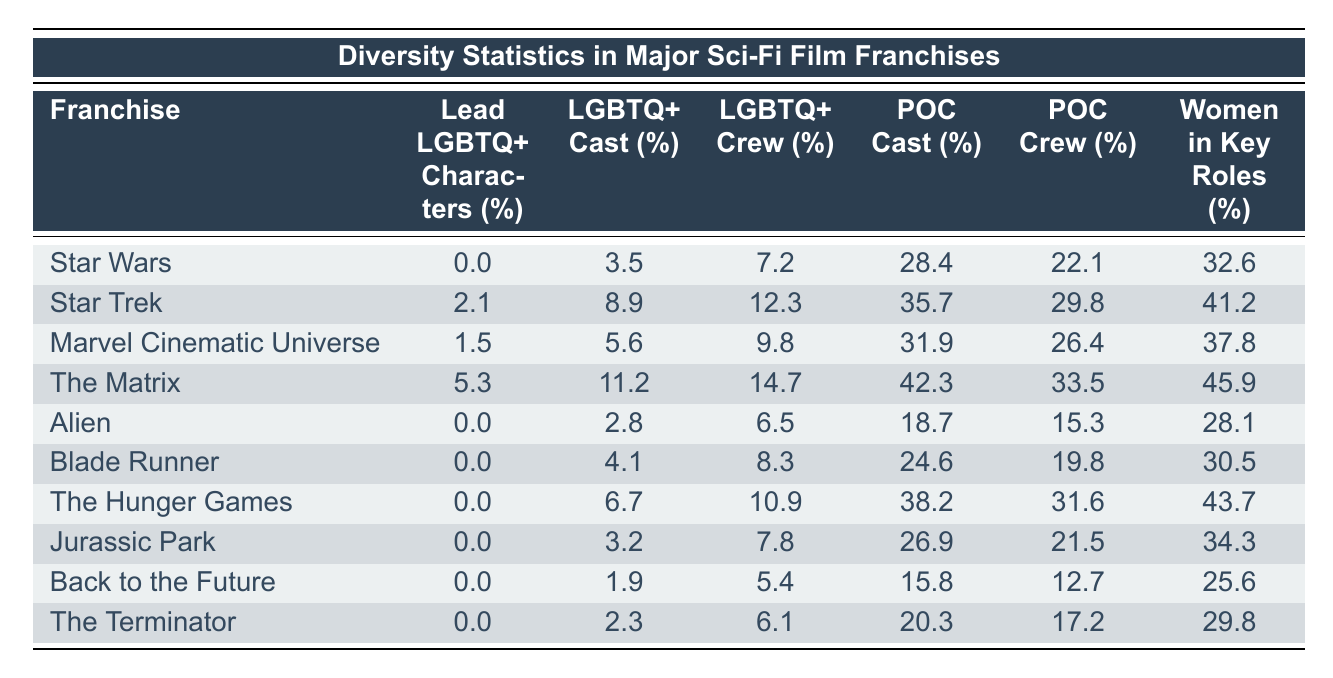What is the percentage of lead LGBTQ+ characters in the "Star Wars" franchise? In the table, under the column "Lead LGBTQ+ Characters (%)" for "Star Wars," the value is 0.0%.
Answer: 0.0% Which franchise has the highest percentage of LGBTQ+ cast? The table shows that "The Matrix" has the highest percentage of LGBTQ+ cast at 11.2%.
Answer: The Matrix What percentage of crew members in the "Star Trek" franchise identify as LGBTQ+? Referring to the "Star Trek" row in the "LGBTQ+ Crew (%)" column, the value is 12.3%.
Answer: 12.3% Which franchise has the lowest percentage of POC cast members? Looking at the "POC Cast (%)" column, "Alien" has the lowest percentage at 18.7%.
Answer: Alien What is the difference in the percentage of women in key roles between "Star Trek" and "The Hunger Games"? For "Star Trek", the percentage of women in key roles is 41.2% and for "The Hunger Games", it’s 43.7%. The difference is 43.7% - 41.2% = 2.5%.
Answer: 2.5% How many franchises have a higher percentage of LGBTQ+ crew than "Jurassic Park"? "Jurassic Park" has an LGBTQ+ crew percentage of 7.8%. The franchises with higher percentages are: "The Matrix" (14.7%), "Star Trek" (12.3%), and "Marvel Cinematic Universe" (9.8%). That makes a total of 3 franchises.
Answer: 3 Which franchise has the highest combined percentage of POC cast and crew? For each franchise, the POC cast and crew percentages must be added. "The Matrix" has 42.3% + 33.5% = 75.8%, which is the highest combined total when compared to other franchises.
Answer: The Matrix Is there any franchise with both a lead LGBTQ+ character and a majority female representation in key roles? Referring to the table, only "The Matrix" has 5.3% lead LGBTQ+ characters and 45.9% women in key roles, which meets the criteria.
Answer: Yes What is the average percentage of LGBTQ+ cast across all franchises listed? Adding the percentages of the LGBTQ+ cast across all franchises (3.5 + 8.9 + 5.6 + 11.2 + 2.8 + 4.1 + 6.7 + 3.2 + 1.9 + 2.3) equals 50.2%. Dividing by the number of franchises (10), the average is 50.2/10 = 5.02%.
Answer: 5.02% Does the "Marvel Cinematic Universe" have a higher percentage of POC crew than "The Matrix"? The "Marvel Cinematic Universe" shows 26.4% for POC crew and "The Matrix" has 33.5%. Since 26.4% is less than 33.5%, the answer is no.
Answer: No 